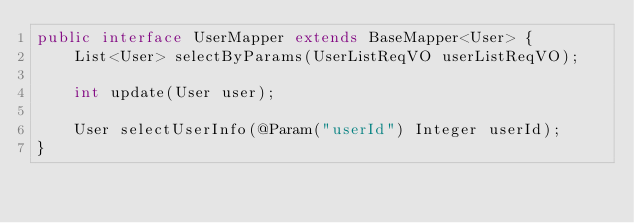Convert code to text. <code><loc_0><loc_0><loc_500><loc_500><_Java_>public interface UserMapper extends BaseMapper<User> {
    List<User> selectByParams(UserListReqVO userListReqVO);

    int update(User user);

    User selectUserInfo(@Param("userId") Integer userId);
}
</code> 